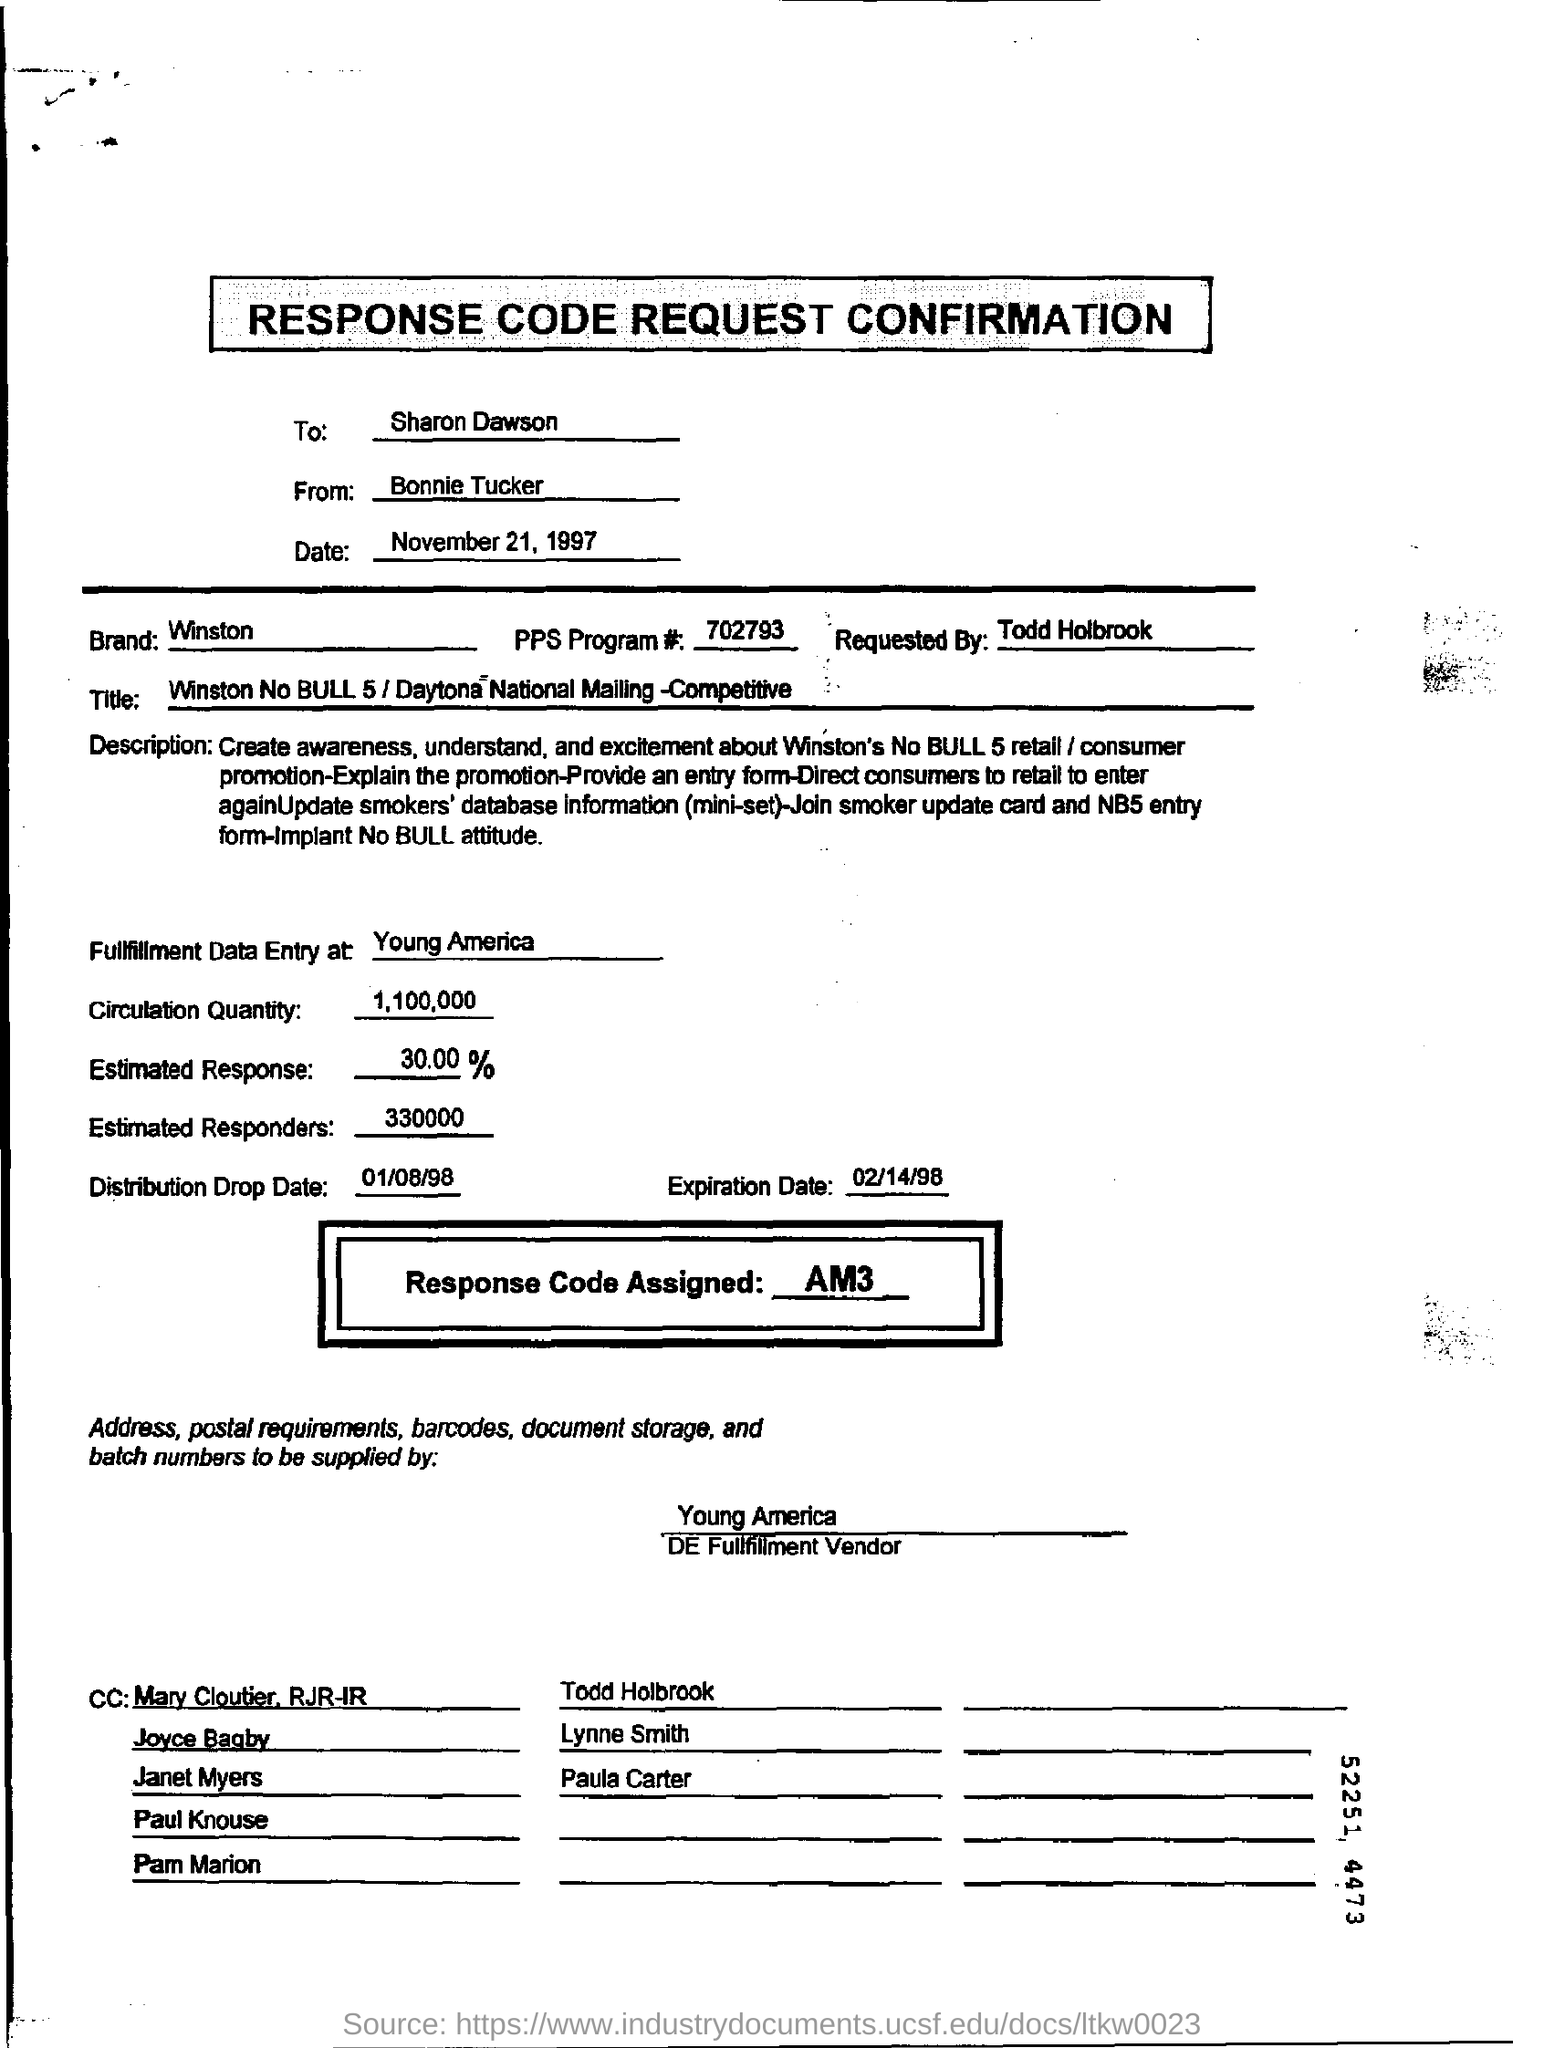Who requested the response code request confirmation form?
Offer a terse response. Todd Holbrook. What is the Brand mentioned on the response code request form?
Ensure brevity in your answer.  Winston. What is the response code request confirmation form dated?
Offer a terse response. November 21, 1997. How many number of estimated responders are mentioned in the form?
Provide a short and direct response. 330000. What is the assigned response code mentioned on the form?
Offer a terse response. AM3. 